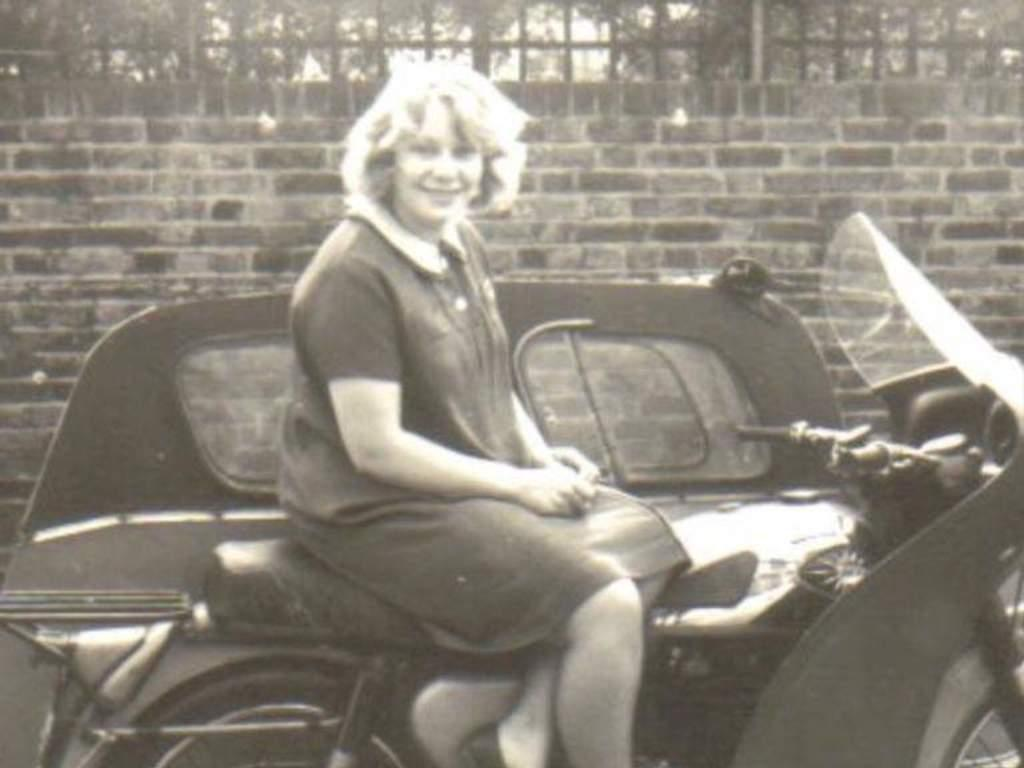Who is present in the image? There is a woman in the image. What is the woman doing in the image? The woman is sitting on a vehicle. What can be seen behind the vehicle? There is a wall behind the vehicle. What other structures are visible in the image? There is a fence in the image. What type of natural elements can be seen in the image? There are trees in the image. How many noses can be seen in the image? There are no noses visible in the image. What type of crowd is present in the image? There is no crowd present in the image; it features a woman sitting on a vehicle. 